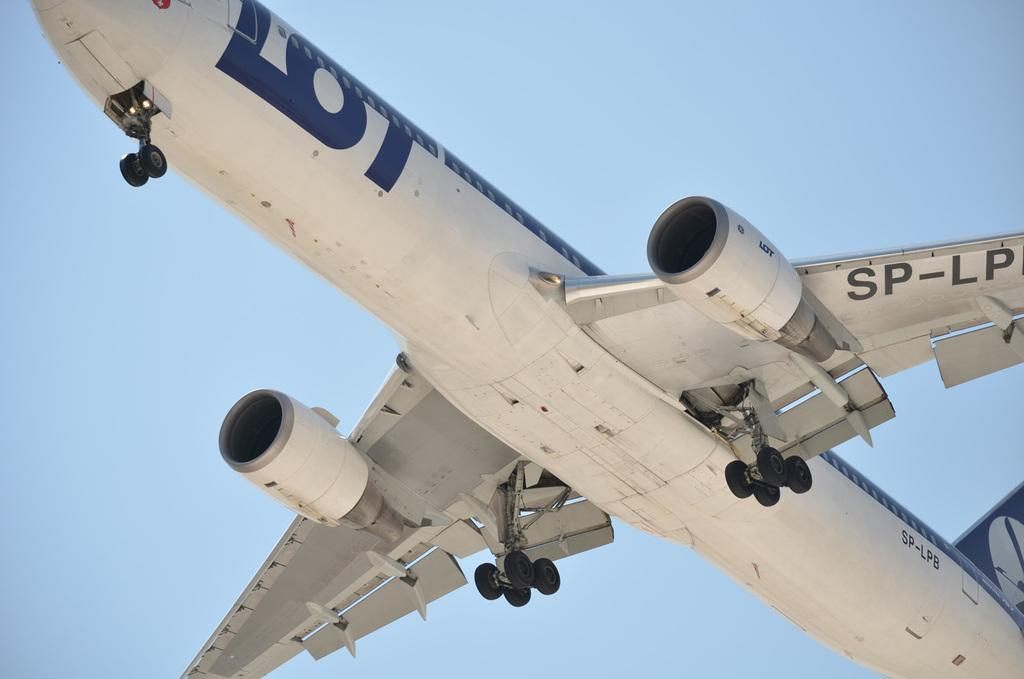What color is the aeroplane in the image? The aeroplane in the image is white. What is the aeroplane doing in the image? The aeroplane is flying in the air. What can be seen at the top of the image? The sky is visible at the top of the image. What type of brush is being used to paint the aeroplane in the image? There is no brush or painting activity depicted in the image; it shows an aeroplane flying in the air. How many crates are visible in the image? There are no crates present in the image. 